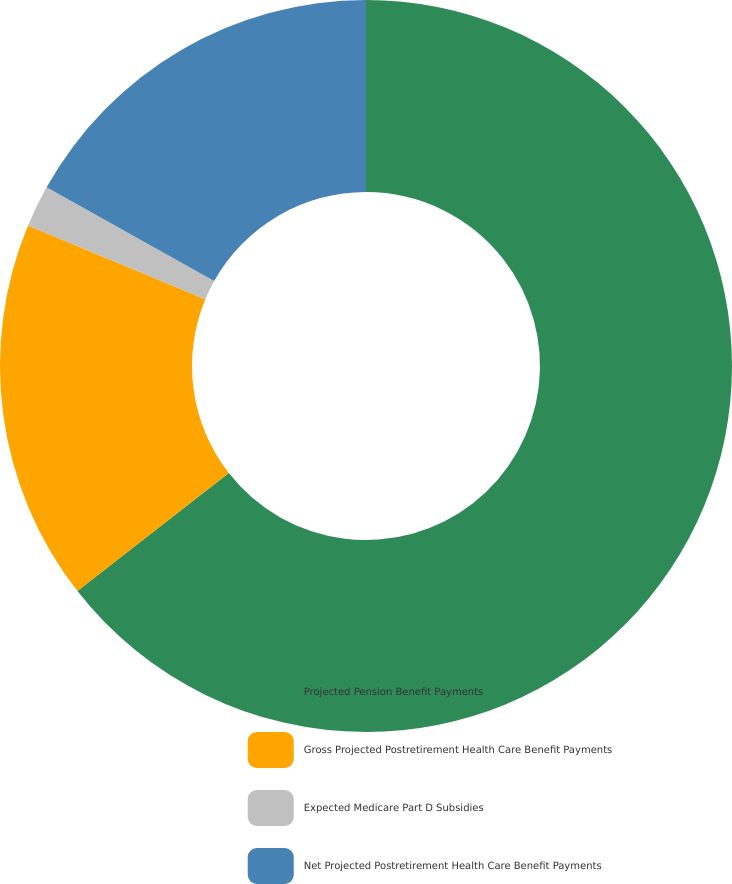Convert chart to OTSL. <chart><loc_0><loc_0><loc_500><loc_500><pie_chart><fcel>Projected Pension Benefit Payments<fcel>Gross Projected Postretirement Health Care Benefit Payments<fcel>Expected Medicare Part D Subsidies<fcel>Net Projected Postretirement Health Care Benefit Payments<nl><fcel>64.45%<fcel>16.81%<fcel>1.85%<fcel>16.88%<nl></chart> 